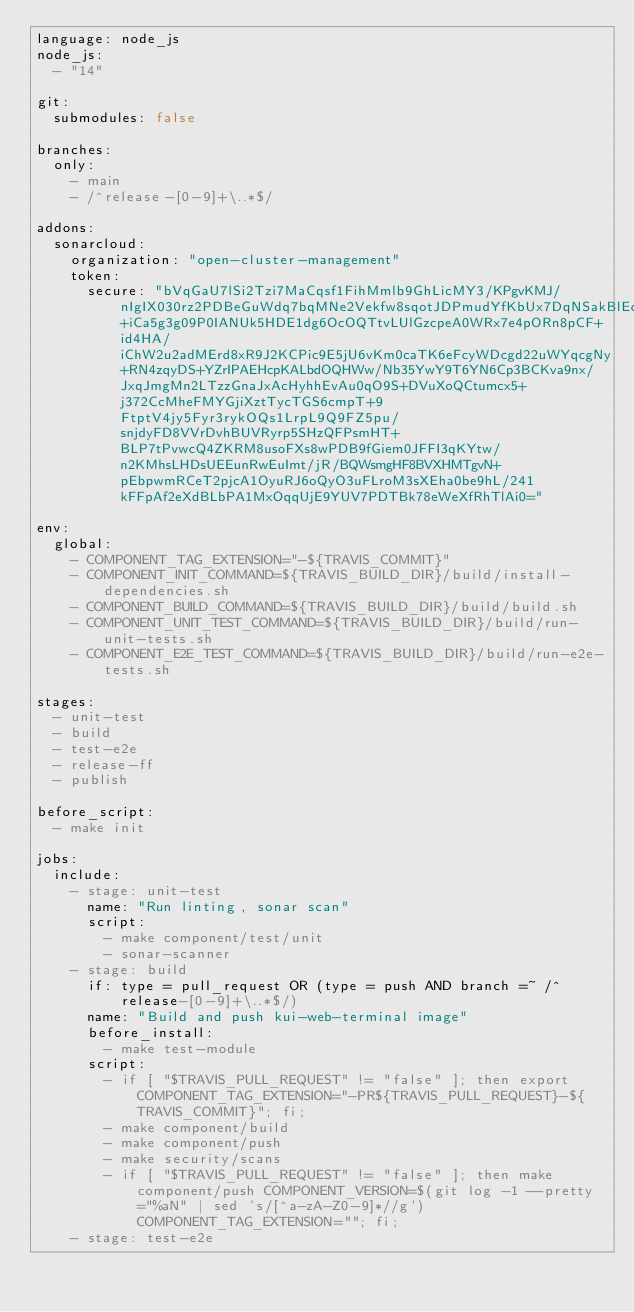<code> <loc_0><loc_0><loc_500><loc_500><_YAML_>language: node_js
node_js:
  - "14"

git:
  submodules: false

branches:
  only:
    - main
    - /^release-[0-9]+\..*$/

addons:
  sonarcloud:
    organization: "open-cluster-management"
    token:
      secure: "bVqGaU7lSi2Tzi7MaCqsf1FihMmlb9GhLicMY3/KPgvKMJ/nIgIX030rz2PDBeGuWdq7bqMNe2Vekfw8sqotJDPmudYfKbUx7DqNSakBlEcwegELDEIMjqslslK9sgqUaiCy4S6eNTS0ogBtRCLkL1s6p2e9IMHD7GQXajjxZu6p6o+iCa5g3g09P0IANUk5HDE1dg6OcOQTtvLUlGzcpeA0WRx7e4pORn8pCF+id4HA/iChW2u2adMErd8xR9J2KCPic9E5jU6vKm0caTK6eFcyWDcgd22uWYqcgNy+RN4zqyDS+YZrIPAEHcpKALbdOQHWw/Nb35YwY9T6YN6Cp3BCKva9nx/JxqJmgMn2LTzzGnaJxAcHyhhEvAu0qO9S+DVuXoQCtumcx5+j372CcMheFMYGjiXztTycTGS6cmpT+9FtptV4jy5Fyr3rykOQs1LrpL9Q9FZ5pu/snjdyFD8VVrDvhBUVRyrp5SHzQFPsmHT+BLP7tPvwcQ4ZKRM8usoFXs8wPDB9fGiem0JFFI3qKYtw/n2KMhsLHDsUEEunRwEuImt/jR/BQWsmgHF8BVXHMTgvN+pEbpwmRCeT2pjcA1OyuRJ6oQyO3uFLroM3sXEha0be9hL/241kFFpAf2eXdBLbPA1MxOqqUjE9YUV7PDTBk78eWeXfRhTlAi0="

env:
  global:
    - COMPONENT_TAG_EXTENSION="-${TRAVIS_COMMIT}"
    - COMPONENT_INIT_COMMAND=${TRAVIS_BUILD_DIR}/build/install-dependencies.sh
    - COMPONENT_BUILD_COMMAND=${TRAVIS_BUILD_DIR}/build/build.sh
    - COMPONENT_UNIT_TEST_COMMAND=${TRAVIS_BUILD_DIR}/build/run-unit-tests.sh
    - COMPONENT_E2E_TEST_COMMAND=${TRAVIS_BUILD_DIR}/build/run-e2e-tests.sh

stages:
  - unit-test
  - build
  - test-e2e
  - release-ff
  - publish

before_script:
  - make init

jobs:
  include:
    - stage: unit-test
      name: "Run linting, sonar scan"
      script:
        - make component/test/unit
        - sonar-scanner
    - stage: build
      if: type = pull_request OR (type = push AND branch =~ /^release-[0-9]+\..*$/)
      name: "Build and push kui-web-terminal image"
      before_install:
        - make test-module
      script:
        - if [ "$TRAVIS_PULL_REQUEST" != "false" ]; then export COMPONENT_TAG_EXTENSION="-PR${TRAVIS_PULL_REQUEST}-${TRAVIS_COMMIT}"; fi;
        - make component/build
        - make component/push
        - make security/scans
        - if [ "$TRAVIS_PULL_REQUEST" != "false" ]; then make component/push COMPONENT_VERSION=$(git log -1 --pretty="%aN" | sed 's/[^a-zA-Z0-9]*//g') COMPONENT_TAG_EXTENSION=""; fi;
    - stage: test-e2e</code> 